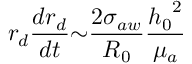Convert formula to latex. <formula><loc_0><loc_0><loc_500><loc_500>r _ { d } \frac { d r _ { d } } { d t } { \sim } \frac { 2 { \sigma } _ { a w } } { R _ { 0 } } \frac { { h _ { 0 } } ^ { 2 } } { { \mu } _ { a } }</formula> 